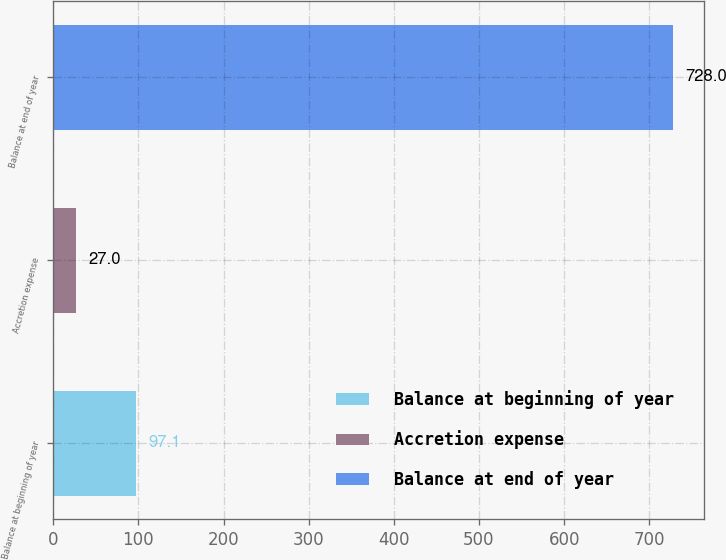Convert chart to OTSL. <chart><loc_0><loc_0><loc_500><loc_500><bar_chart><fcel>Balance at beginning of year<fcel>Accretion expense<fcel>Balance at end of year<nl><fcel>97.1<fcel>27<fcel>728<nl></chart> 